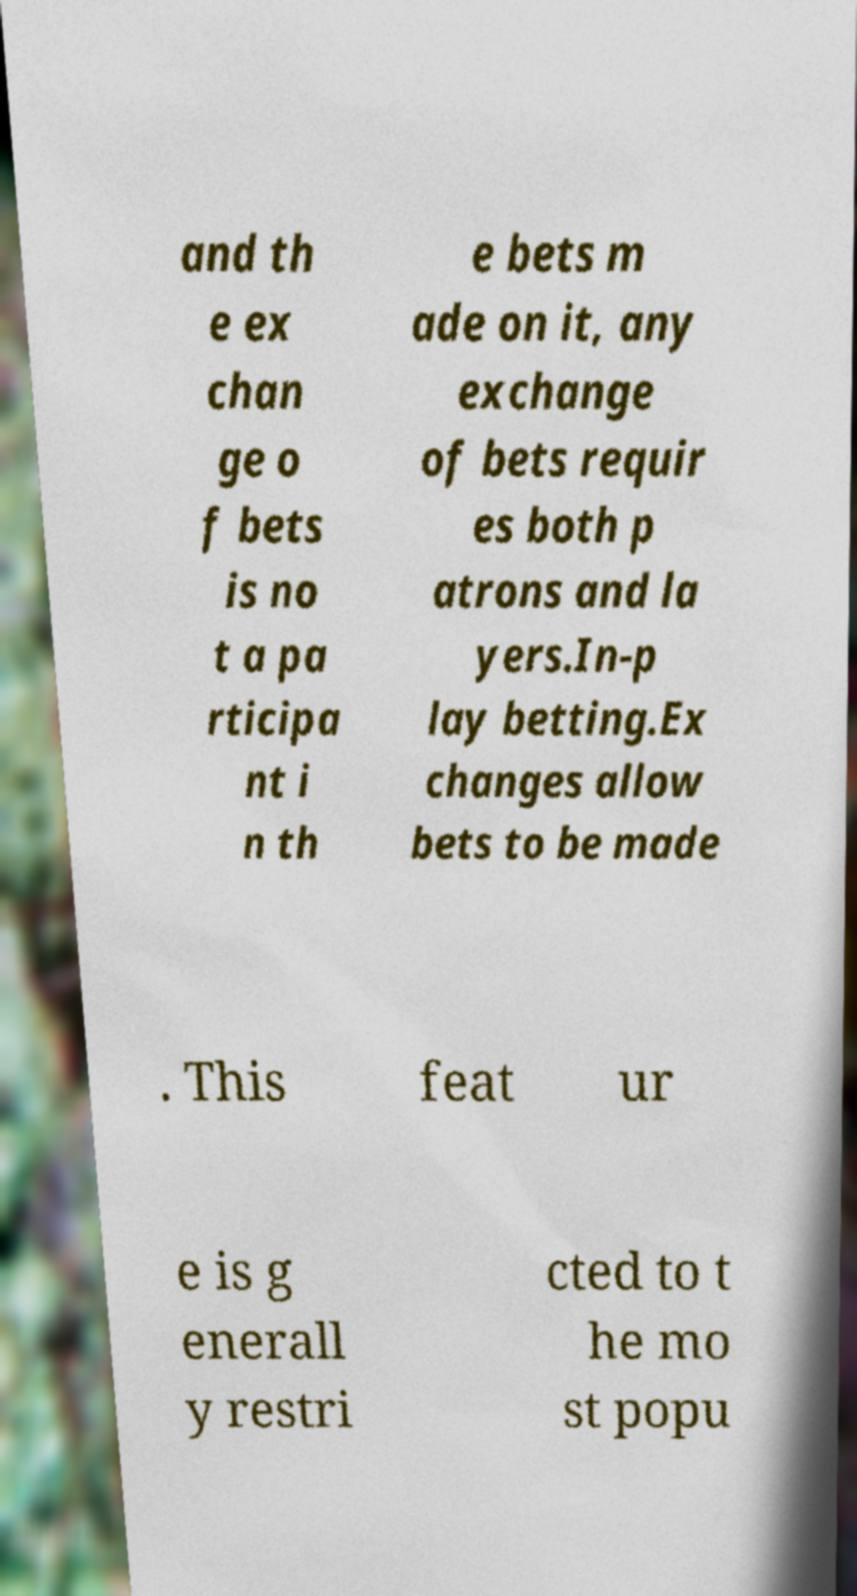For documentation purposes, I need the text within this image transcribed. Could you provide that? and th e ex chan ge o f bets is no t a pa rticipa nt i n th e bets m ade on it, any exchange of bets requir es both p atrons and la yers.In-p lay betting.Ex changes allow bets to be made . This feat ur e is g enerall y restri cted to t he mo st popu 